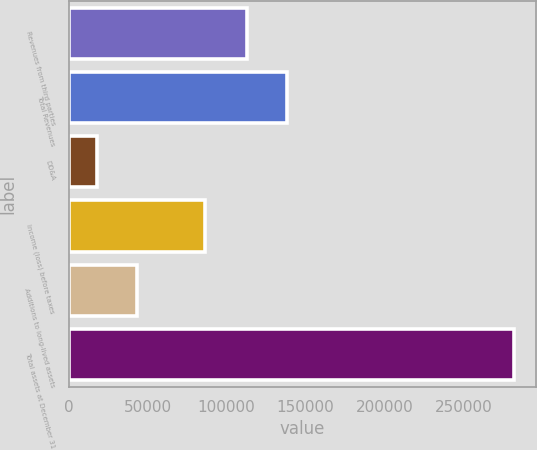<chart> <loc_0><loc_0><loc_500><loc_500><bar_chart><fcel>Revenues from third parties<fcel>Total Revenues<fcel>DD&A<fcel>Income (loss) before taxes<fcel>Additions to long-lived assets<fcel>Total assets at December 31<nl><fcel>113001<fcel>138055<fcel>17842<fcel>86022<fcel>42896.4<fcel>281967<nl></chart> 